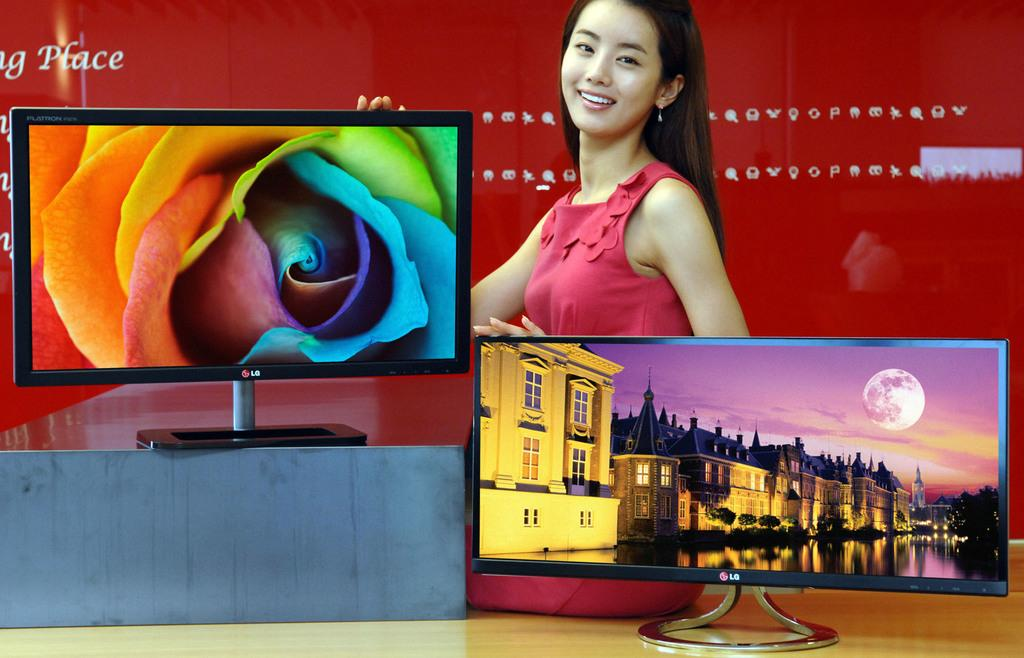<image>
Create a compact narrative representing the image presented. A woman standing behind a display of LG monitors. 